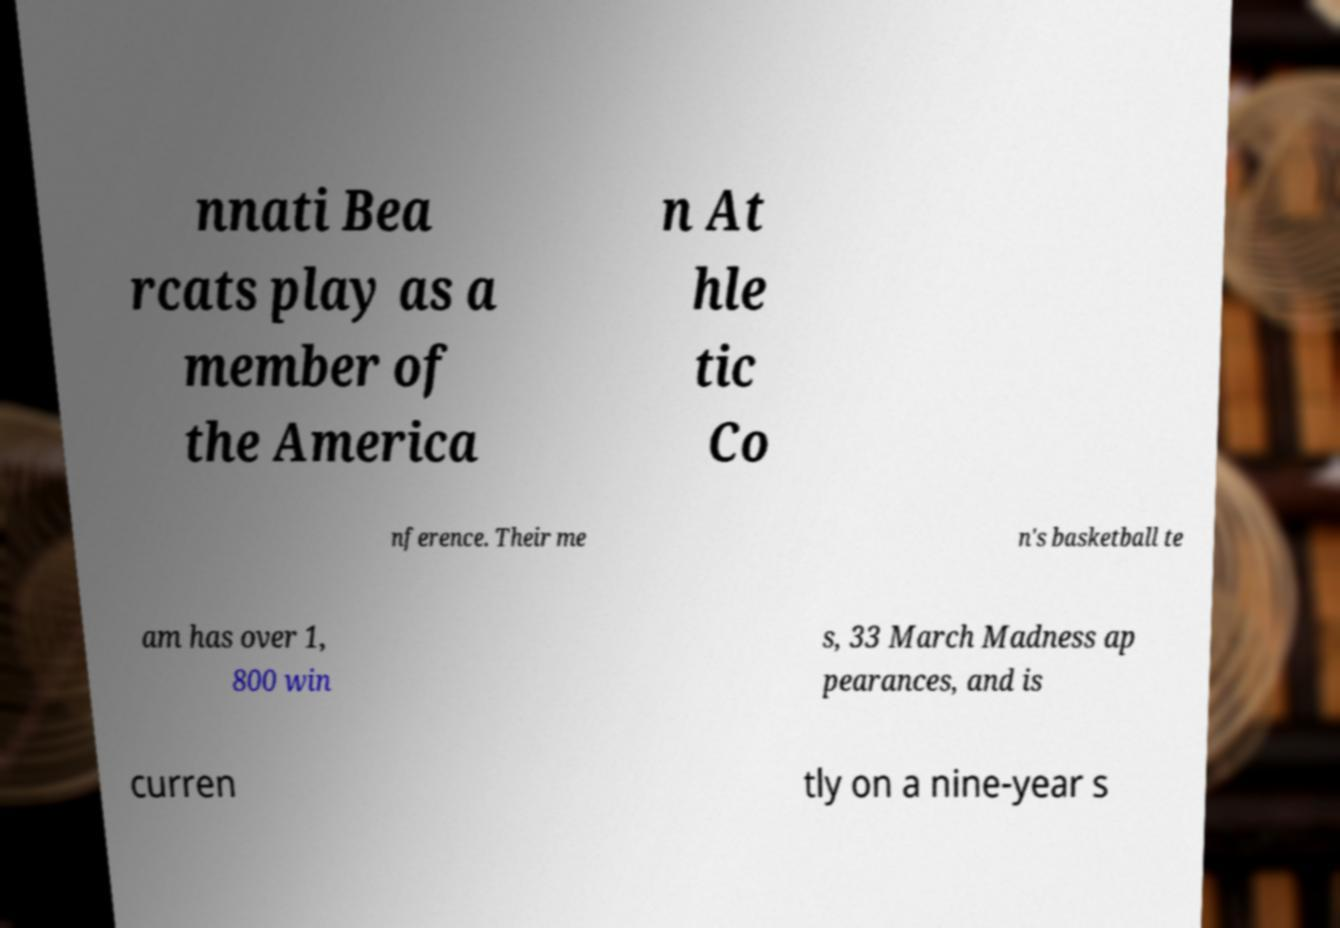What messages or text are displayed in this image? I need them in a readable, typed format. nnati Bea rcats play as a member of the America n At hle tic Co nference. Their me n's basketball te am has over 1, 800 win s, 33 March Madness ap pearances, and is curren tly on a nine-year s 